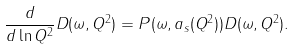Convert formula to latex. <formula><loc_0><loc_0><loc_500><loc_500>\frac { d } { d \ln Q ^ { 2 } } D ( \omega , Q ^ { 2 } ) = P ( \omega , a _ { s } ( Q ^ { 2 } ) ) D ( \omega , Q ^ { 2 } ) .</formula> 